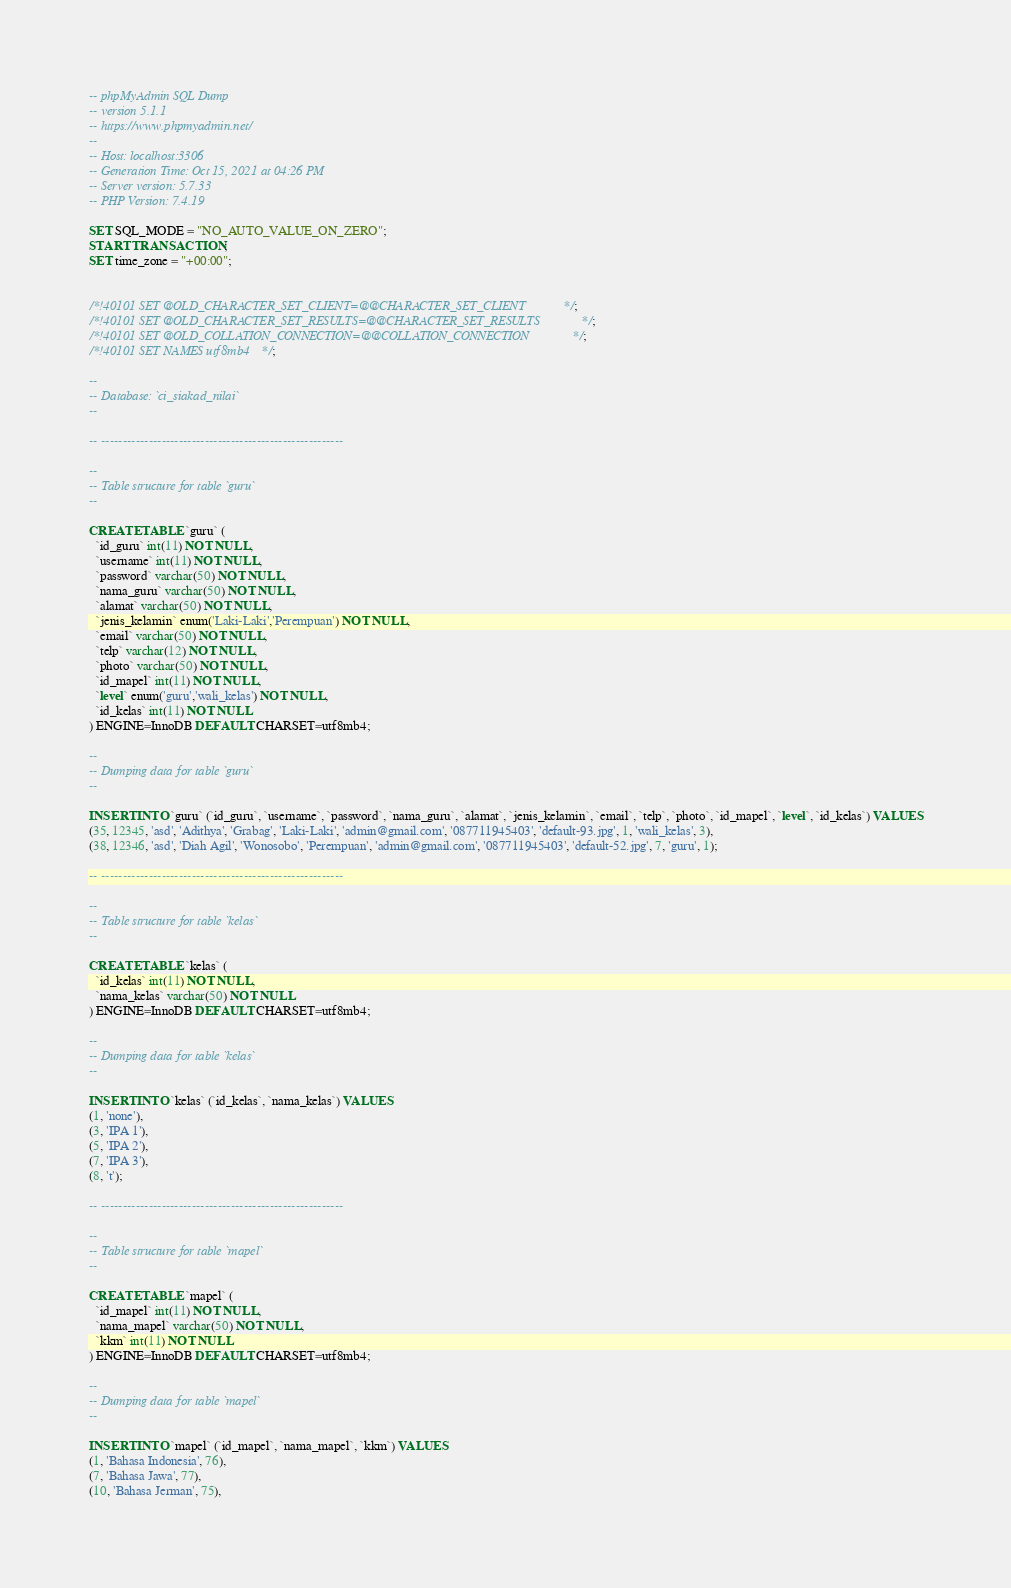<code> <loc_0><loc_0><loc_500><loc_500><_SQL_>-- phpMyAdmin SQL Dump
-- version 5.1.1
-- https://www.phpmyadmin.net/
--
-- Host: localhost:3306
-- Generation Time: Oct 15, 2021 at 04:26 PM
-- Server version: 5.7.33
-- PHP Version: 7.4.19

SET SQL_MODE = "NO_AUTO_VALUE_ON_ZERO";
START TRANSACTION;
SET time_zone = "+00:00";


/*!40101 SET @OLD_CHARACTER_SET_CLIENT=@@CHARACTER_SET_CLIENT */;
/*!40101 SET @OLD_CHARACTER_SET_RESULTS=@@CHARACTER_SET_RESULTS */;
/*!40101 SET @OLD_COLLATION_CONNECTION=@@COLLATION_CONNECTION */;
/*!40101 SET NAMES utf8mb4 */;

--
-- Database: `ci_siakad_nilai`
--

-- --------------------------------------------------------

--
-- Table structure for table `guru`
--

CREATE TABLE `guru` (
  `id_guru` int(11) NOT NULL,
  `username` int(11) NOT NULL,
  `password` varchar(50) NOT NULL,
  `nama_guru` varchar(50) NOT NULL,
  `alamat` varchar(50) NOT NULL,
  `jenis_kelamin` enum('Laki-Laki','Perempuan') NOT NULL,
  `email` varchar(50) NOT NULL,
  `telp` varchar(12) NOT NULL,
  `photo` varchar(50) NOT NULL,
  `id_mapel` int(11) NOT NULL,
  `level` enum('guru','wali_kelas') NOT NULL,
  `id_kelas` int(11) NOT NULL
) ENGINE=InnoDB DEFAULT CHARSET=utf8mb4;

--
-- Dumping data for table `guru`
--

INSERT INTO `guru` (`id_guru`, `username`, `password`, `nama_guru`, `alamat`, `jenis_kelamin`, `email`, `telp`, `photo`, `id_mapel`, `level`, `id_kelas`) VALUES
(35, 12345, 'asd', 'Adithya', 'Grabag', 'Laki-Laki', 'admin@gmail.com', '087711945403', 'default-93.jpg', 1, 'wali_kelas', 3),
(38, 12346, 'asd', 'Diah Agil', 'Wonosobo', 'Perempuan', 'admin@gmail.com', '087711945403', 'default-52.jpg', 7, 'guru', 1);

-- --------------------------------------------------------

--
-- Table structure for table `kelas`
--

CREATE TABLE `kelas` (
  `id_kelas` int(11) NOT NULL,
  `nama_kelas` varchar(50) NOT NULL
) ENGINE=InnoDB DEFAULT CHARSET=utf8mb4;

--
-- Dumping data for table `kelas`
--

INSERT INTO `kelas` (`id_kelas`, `nama_kelas`) VALUES
(1, 'none'),
(3, 'IPA 1'),
(5, 'IPA 2'),
(7, 'IPA 3'),
(8, 't');

-- --------------------------------------------------------

--
-- Table structure for table `mapel`
--

CREATE TABLE `mapel` (
  `id_mapel` int(11) NOT NULL,
  `nama_mapel` varchar(50) NOT NULL,
  `kkm` int(11) NOT NULL
) ENGINE=InnoDB DEFAULT CHARSET=utf8mb4;

--
-- Dumping data for table `mapel`
--

INSERT INTO `mapel` (`id_mapel`, `nama_mapel`, `kkm`) VALUES
(1, 'Bahasa Indonesia', 76),
(7, 'Bahasa Jawa', 77),
(10, 'Bahasa Jerman', 75),</code> 